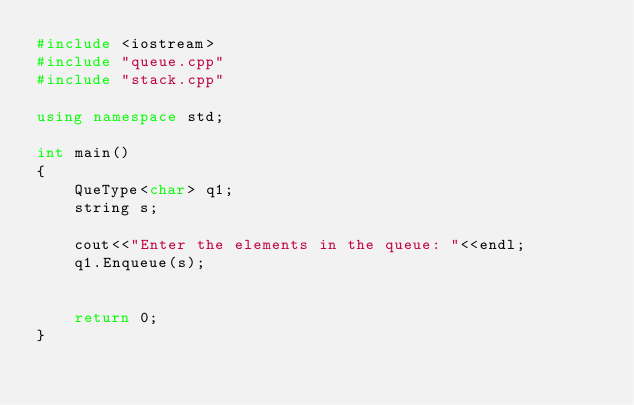<code> <loc_0><loc_0><loc_500><loc_500><_C++_>#include <iostream>
#include "queue.cpp"
#include "stack.cpp"

using namespace std;

int main()
{
    QueType<char> q1;
    string s;

    cout<<"Enter the elements in the queue: "<<endl;
    q1.Enqueue(s);


    return 0;
}
</code> 